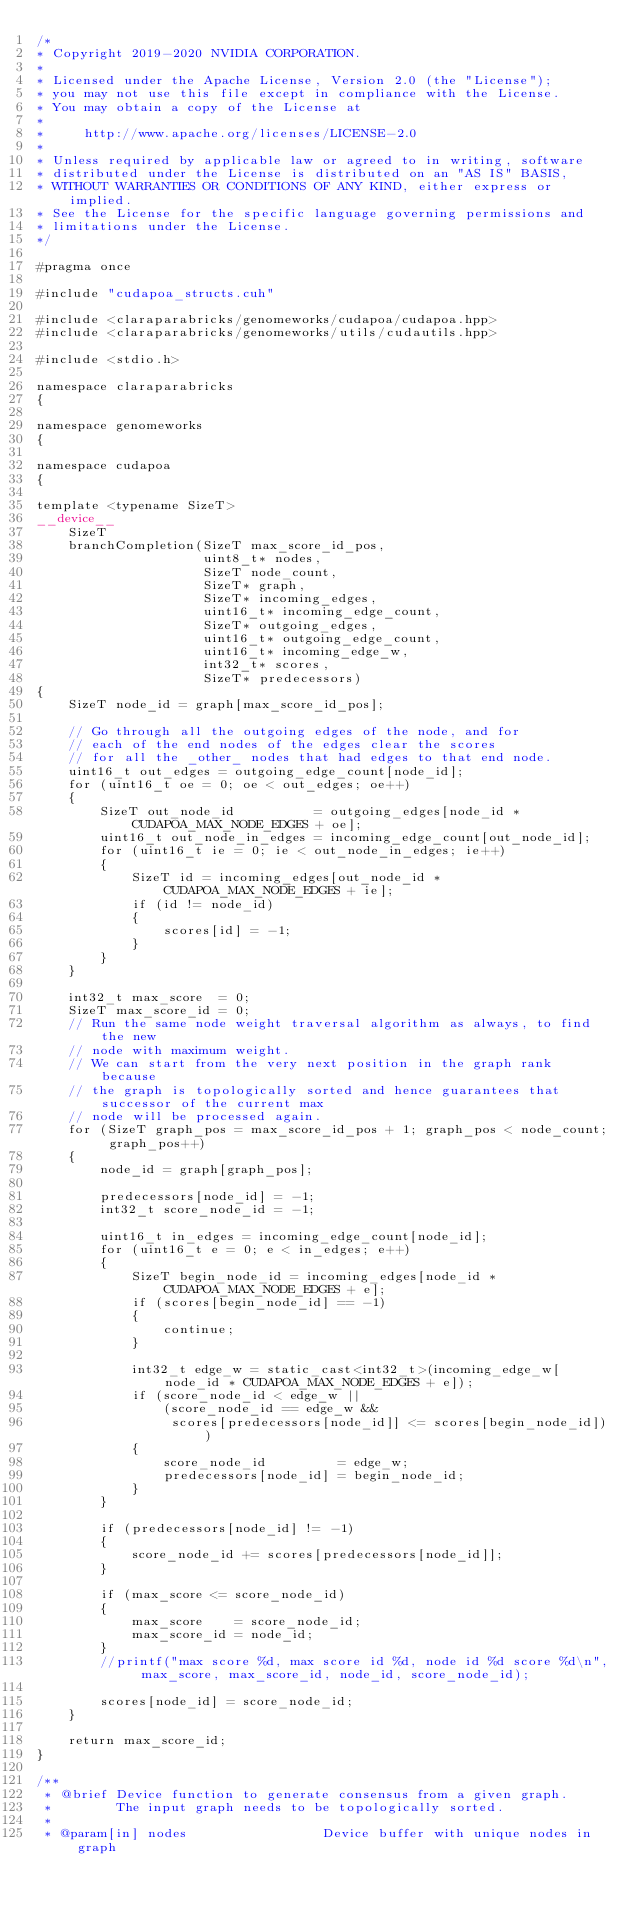Convert code to text. <code><loc_0><loc_0><loc_500><loc_500><_Cuda_>/*
* Copyright 2019-2020 NVIDIA CORPORATION.
*
* Licensed under the Apache License, Version 2.0 (the "License");
* you may not use this file except in compliance with the License.
* You may obtain a copy of the License at
*
*     http://www.apache.org/licenses/LICENSE-2.0
*
* Unless required by applicable law or agreed to in writing, software
* distributed under the License is distributed on an "AS IS" BASIS,
* WITHOUT WARRANTIES OR CONDITIONS OF ANY KIND, either express or implied.
* See the License for the specific language governing permissions and
* limitations under the License.
*/

#pragma once

#include "cudapoa_structs.cuh"

#include <claraparabricks/genomeworks/cudapoa/cudapoa.hpp>
#include <claraparabricks/genomeworks/utils/cudautils.hpp>

#include <stdio.h>

namespace claraparabricks
{

namespace genomeworks
{

namespace cudapoa
{

template <typename SizeT>
__device__
    SizeT
    branchCompletion(SizeT max_score_id_pos,
                     uint8_t* nodes,
                     SizeT node_count,
                     SizeT* graph,
                     SizeT* incoming_edges,
                     uint16_t* incoming_edge_count,
                     SizeT* outgoing_edges,
                     uint16_t* outgoing_edge_count,
                     uint16_t* incoming_edge_w,
                     int32_t* scores,
                     SizeT* predecessors)
{
    SizeT node_id = graph[max_score_id_pos];

    // Go through all the outgoing edges of the node, and for
    // each of the end nodes of the edges clear the scores
    // for all the _other_ nodes that had edges to that end node.
    uint16_t out_edges = outgoing_edge_count[node_id];
    for (uint16_t oe = 0; oe < out_edges; oe++)
    {
        SizeT out_node_id          = outgoing_edges[node_id * CUDAPOA_MAX_NODE_EDGES + oe];
        uint16_t out_node_in_edges = incoming_edge_count[out_node_id];
        for (uint16_t ie = 0; ie < out_node_in_edges; ie++)
        {
            SizeT id = incoming_edges[out_node_id * CUDAPOA_MAX_NODE_EDGES + ie];
            if (id != node_id)
            {
                scores[id] = -1;
            }
        }
    }

    int32_t max_score  = 0;
    SizeT max_score_id = 0;
    // Run the same node weight traversal algorithm as always, to find the new
    // node with maximum weight.
    // We can start from the very next position in the graph rank because
    // the graph is topologically sorted and hence guarantees that successor of the current max
    // node will be processed again.
    for (SizeT graph_pos = max_score_id_pos + 1; graph_pos < node_count; graph_pos++)
    {
        node_id = graph[graph_pos];

        predecessors[node_id] = -1;
        int32_t score_node_id = -1;

        uint16_t in_edges = incoming_edge_count[node_id];
        for (uint16_t e = 0; e < in_edges; e++)
        {
            SizeT begin_node_id = incoming_edges[node_id * CUDAPOA_MAX_NODE_EDGES + e];
            if (scores[begin_node_id] == -1)
            {
                continue;
            }

            int32_t edge_w = static_cast<int32_t>(incoming_edge_w[node_id * CUDAPOA_MAX_NODE_EDGES + e]);
            if (score_node_id < edge_w ||
                (score_node_id == edge_w &&
                 scores[predecessors[node_id]] <= scores[begin_node_id]))
            {
                score_node_id         = edge_w;
                predecessors[node_id] = begin_node_id;
            }
        }

        if (predecessors[node_id] != -1)
        {
            score_node_id += scores[predecessors[node_id]];
        }

        if (max_score <= score_node_id)
        {
            max_score    = score_node_id;
            max_score_id = node_id;
        }
        //printf("max score %d, max score id %d, node id %d score %d\n", max_score, max_score_id, node_id, score_node_id);

        scores[node_id] = score_node_id;
    }

    return max_score_id;
}

/**
 * @brief Device function to generate consensus from a given graph.
 *        The input graph needs to be topologically sorted.
 *
 * @param[in] nodes                 Device buffer with unique nodes in graph</code> 